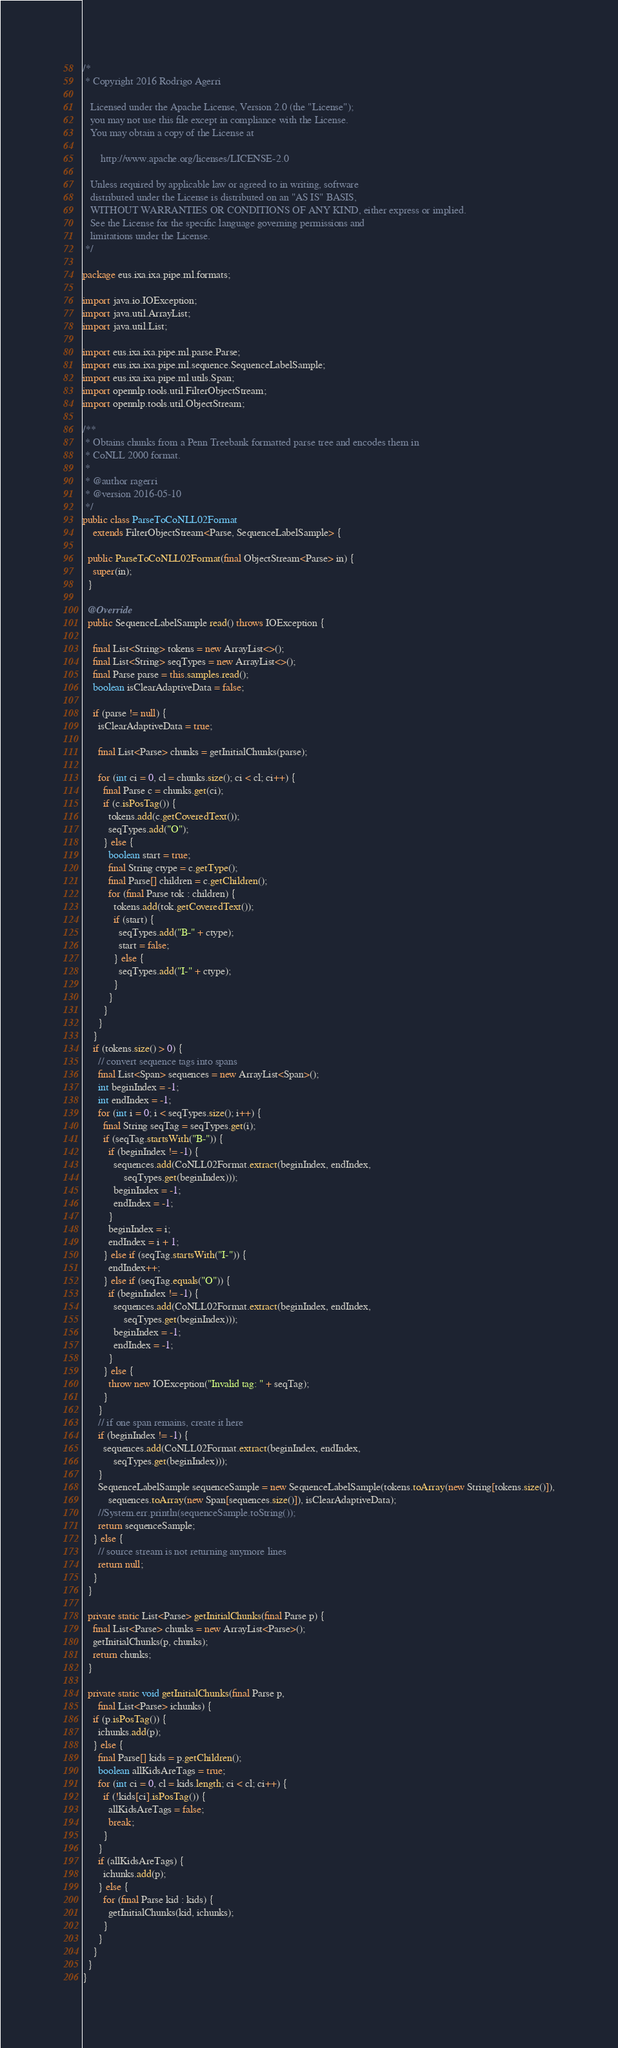Convert code to text. <code><loc_0><loc_0><loc_500><loc_500><_Java_>/*
 * Copyright 2016 Rodrigo Agerri

   Licensed under the Apache License, Version 2.0 (the "License");
   you may not use this file except in compliance with the License.
   You may obtain a copy of the License at

       http://www.apache.org/licenses/LICENSE-2.0

   Unless required by applicable law or agreed to in writing, software
   distributed under the License is distributed on an "AS IS" BASIS,
   WITHOUT WARRANTIES OR CONDITIONS OF ANY KIND, either express or implied.
   See the License for the specific language governing permissions and
   limitations under the License.
 */

package eus.ixa.ixa.pipe.ml.formats;

import java.io.IOException;
import java.util.ArrayList;
import java.util.List;

import eus.ixa.ixa.pipe.ml.parse.Parse;
import eus.ixa.ixa.pipe.ml.sequence.SequenceLabelSample;
import eus.ixa.ixa.pipe.ml.utils.Span;
import opennlp.tools.util.FilterObjectStream;
import opennlp.tools.util.ObjectStream;

/**
 * Obtains chunks from a Penn Treebank formatted parse tree and encodes them in
 * CoNLL 2000 format.
 * 
 * @author ragerri
 * @version 2016-05-10
 */
public class ParseToCoNLL02Format
    extends FilterObjectStream<Parse, SequenceLabelSample> {

  public ParseToCoNLL02Format(final ObjectStream<Parse> in) {
    super(in);
  }

  @Override
  public SequenceLabelSample read() throws IOException {

    final List<String> tokens = new ArrayList<>();
    final List<String> seqTypes = new ArrayList<>();
    final Parse parse = this.samples.read();
    boolean isClearAdaptiveData = false;

    if (parse != null) {
      isClearAdaptiveData = true;

      final List<Parse> chunks = getInitialChunks(parse);

      for (int ci = 0, cl = chunks.size(); ci < cl; ci++) {
        final Parse c = chunks.get(ci);
        if (c.isPosTag()) {
          tokens.add(c.getCoveredText());
          seqTypes.add("O");
        } else {
          boolean start = true;
          final String ctype = c.getType();
          final Parse[] children = c.getChildren();
          for (final Parse tok : children) {
            tokens.add(tok.getCoveredText());
            if (start) {
              seqTypes.add("B-" + ctype);
              start = false;
            } else {
              seqTypes.add("I-" + ctype);
            }
          }
        }
      }
    }
    if (tokens.size() > 0) {
      // convert sequence tags into spans
      final List<Span> sequences = new ArrayList<Span>();
      int beginIndex = -1;
      int endIndex = -1;
      for (int i = 0; i < seqTypes.size(); i++) {
        final String seqTag = seqTypes.get(i);
        if (seqTag.startsWith("B-")) {
          if (beginIndex != -1) {
            sequences.add(CoNLL02Format.extract(beginIndex, endIndex,
                seqTypes.get(beginIndex)));
            beginIndex = -1;
            endIndex = -1;
          }
          beginIndex = i;
          endIndex = i + 1;
        } else if (seqTag.startsWith("I-")) {
          endIndex++;
        } else if (seqTag.equals("O")) {
          if (beginIndex != -1) {
            sequences.add(CoNLL02Format.extract(beginIndex, endIndex,
                seqTypes.get(beginIndex)));
            beginIndex = -1;
            endIndex = -1;
          }
        } else {
          throw new IOException("Invalid tag: " + seqTag);
        }
      }
      // if one span remains, create it here
      if (beginIndex != -1) {
        sequences.add(CoNLL02Format.extract(beginIndex, endIndex,
            seqTypes.get(beginIndex)));
      }
      SequenceLabelSample sequenceSample = new SequenceLabelSample(tokens.toArray(new String[tokens.size()]),
          sequences.toArray(new Span[sequences.size()]), isClearAdaptiveData);
      //System.err.println(sequenceSample.toString());
      return sequenceSample; 
    } else {
      // source stream is not returning anymore lines
      return null;
    }
  }

  private static List<Parse> getInitialChunks(final Parse p) {
    final List<Parse> chunks = new ArrayList<Parse>();
    getInitialChunks(p, chunks);
    return chunks;
  }

  private static void getInitialChunks(final Parse p,
      final List<Parse> ichunks) {
    if (p.isPosTag()) {
      ichunks.add(p);
    } else {
      final Parse[] kids = p.getChildren();
      boolean allKidsAreTags = true;
      for (int ci = 0, cl = kids.length; ci < cl; ci++) {
        if (!kids[ci].isPosTag()) {
          allKidsAreTags = false;
          break;
        }
      }
      if (allKidsAreTags) {
        ichunks.add(p);
      } else {
        for (final Parse kid : kids) {
          getInitialChunks(kid, ichunks);
        }
      }
    }
  }
}
</code> 